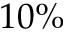<formula> <loc_0><loc_0><loc_500><loc_500>1 0 \%</formula> 